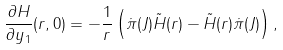<formula> <loc_0><loc_0><loc_500><loc_500>\frac { \partial H } { \partial y _ { 1 } } ( r , 0 ) = - { \frac { 1 } { r } } \left ( \dot { \pi } ( J ) \tilde { H } ( r ) - \tilde { H } ( r ) \dot { \pi } ( J ) \right ) ,</formula> 